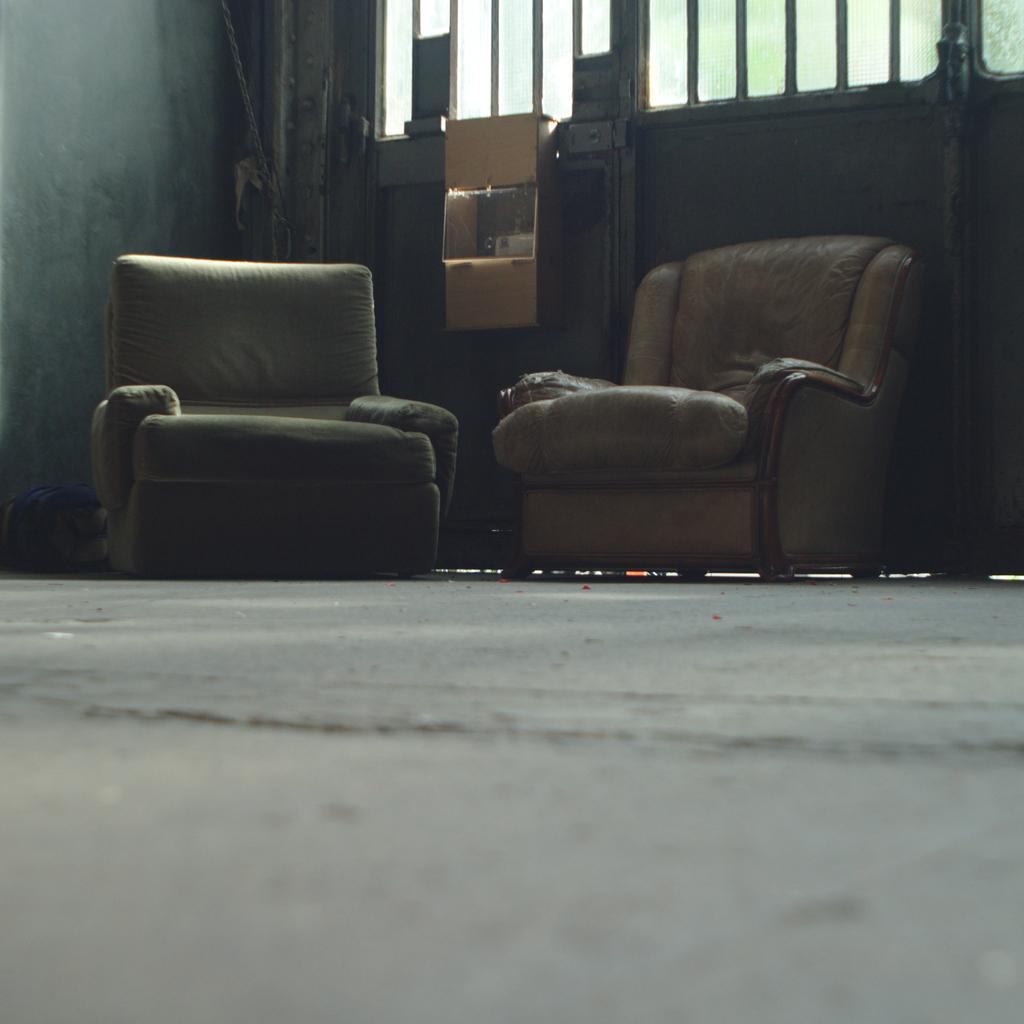What type of furniture is placed on the ground in the image? There are sofas placed on the ground in the image. What can be seen in the background of the image? There are windows, a chain, and a wall visible in the background of the image. What month is it in the image? The month cannot be determined from the image, as it does not contain any information about the time of year. 